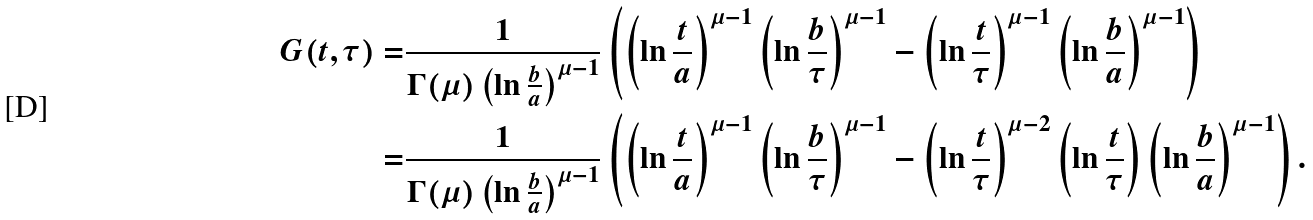<formula> <loc_0><loc_0><loc_500><loc_500>G ( t , \tau ) = & \frac { 1 } { \Gamma ( \mu ) \left ( \ln \frac { b } { a } \right ) ^ { \mu - 1 } } \left ( \left ( \ln \frac { t } { a } \right ) ^ { \mu - 1 } \left ( \ln \frac { b } { \tau } \right ) ^ { \mu - 1 } - \left ( \ln \frac { t } { \tau } \right ) ^ { \mu - 1 } \left ( \ln \frac { b } { a } \right ) ^ { \mu - 1 } \right ) \\ = & \frac { 1 } { \Gamma ( \mu ) \left ( \ln \frac { b } { a } \right ) ^ { \mu - 1 } } \left ( \left ( \ln \frac { t } { a } \right ) ^ { \mu - 1 } \left ( \ln \frac { b } { \tau } \right ) ^ { \mu - 1 } - \left ( \ln \frac { t } { \tau } \right ) ^ { \mu - 2 } \left ( \ln \frac { t } { \tau } \right ) \left ( \ln \frac { b } { a } \right ) ^ { \mu - 1 } \right ) .</formula> 